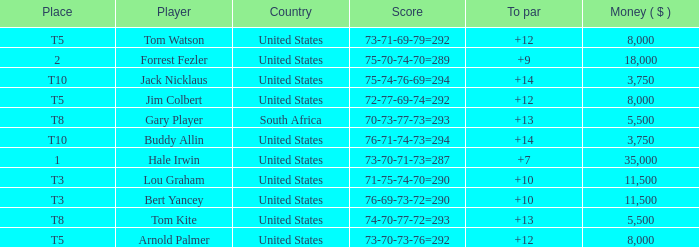Which country's score of 72-77-69-74=292 resulted in a reward of over $5,500? United States. 